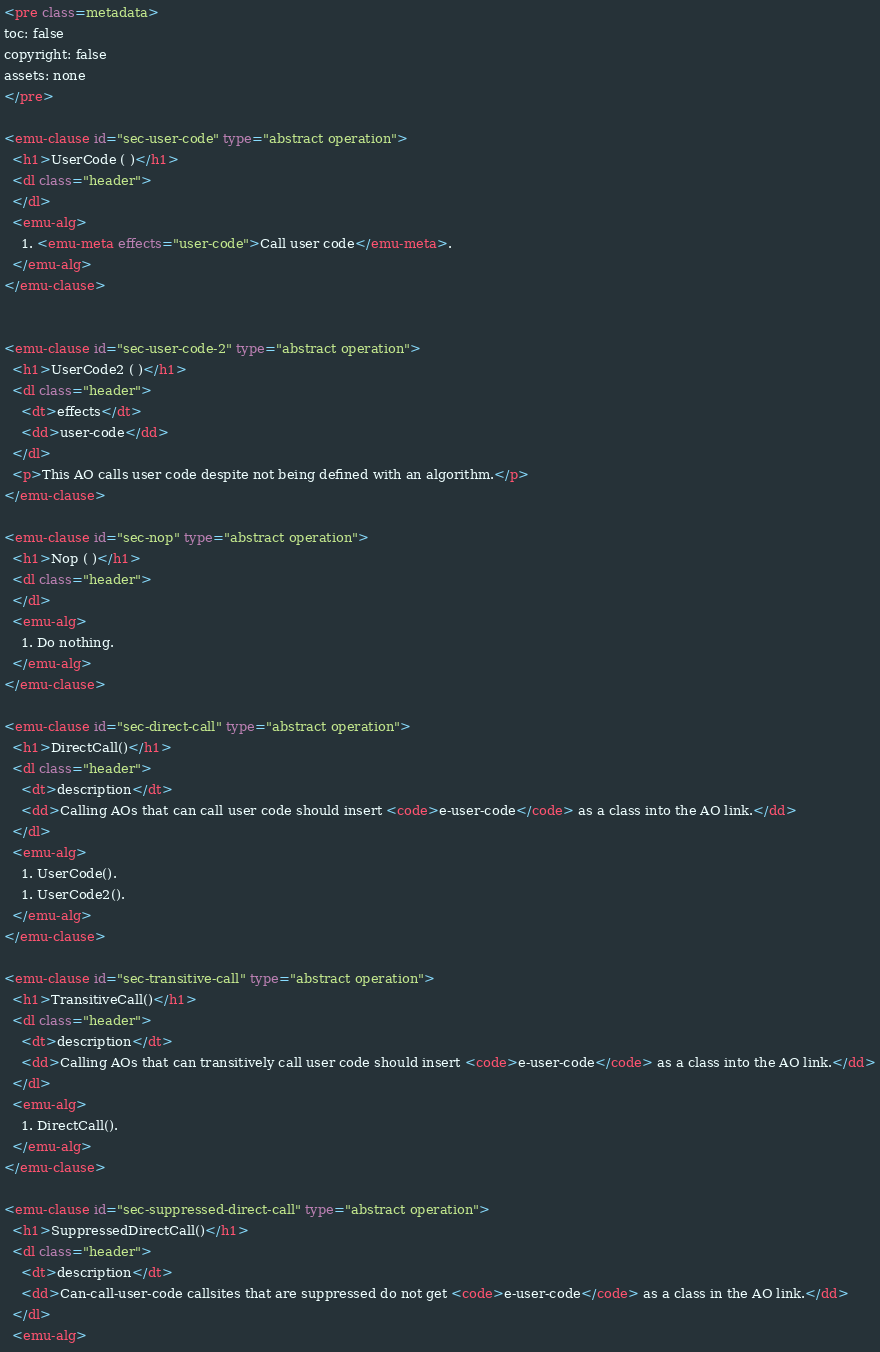Convert code to text. <code><loc_0><loc_0><loc_500><loc_500><_HTML_><pre class=metadata>
toc: false
copyright: false
assets: none
</pre>

<emu-clause id="sec-user-code" type="abstract operation">
  <h1>UserCode ( )</h1>
  <dl class="header">
  </dl>
  <emu-alg>
    1. <emu-meta effects="user-code">Call user code</emu-meta>.
  </emu-alg>
</emu-clause>


<emu-clause id="sec-user-code-2" type="abstract operation">
  <h1>UserCode2 ( )</h1>
  <dl class="header">
    <dt>effects</dt>
    <dd>user-code</dd>
  </dl>
  <p>This AO calls user code despite not being defined with an algorithm.</p>
</emu-clause>

<emu-clause id="sec-nop" type="abstract operation">
  <h1>Nop ( )</h1>
  <dl class="header">
  </dl>
  <emu-alg>
    1. Do nothing.
  </emu-alg>
</emu-clause>

<emu-clause id="sec-direct-call" type="abstract operation">
  <h1>DirectCall()</h1>
  <dl class="header">
    <dt>description</dt>
    <dd>Calling AOs that can call user code should insert <code>e-user-code</code> as a class into the AO link.</dd>
  </dl>
  <emu-alg>
    1. UserCode().
    1. UserCode2().
  </emu-alg>
</emu-clause>

<emu-clause id="sec-transitive-call" type="abstract operation">
  <h1>TransitiveCall()</h1>
  <dl class="header">
    <dt>description</dt>
    <dd>Calling AOs that can transitively call user code should insert <code>e-user-code</code> as a class into the AO link.</dd>
  </dl>
  <emu-alg>
    1. DirectCall().
  </emu-alg>
</emu-clause>

<emu-clause id="sec-suppressed-direct-call" type="abstract operation">
  <h1>SuppressedDirectCall()</h1>
  <dl class="header">
    <dt>description</dt>
    <dd>Can-call-user-code callsites that are suppressed do not get <code>e-user-code</code> as a class in the AO link.</dd>
  </dl>
  <emu-alg></code> 